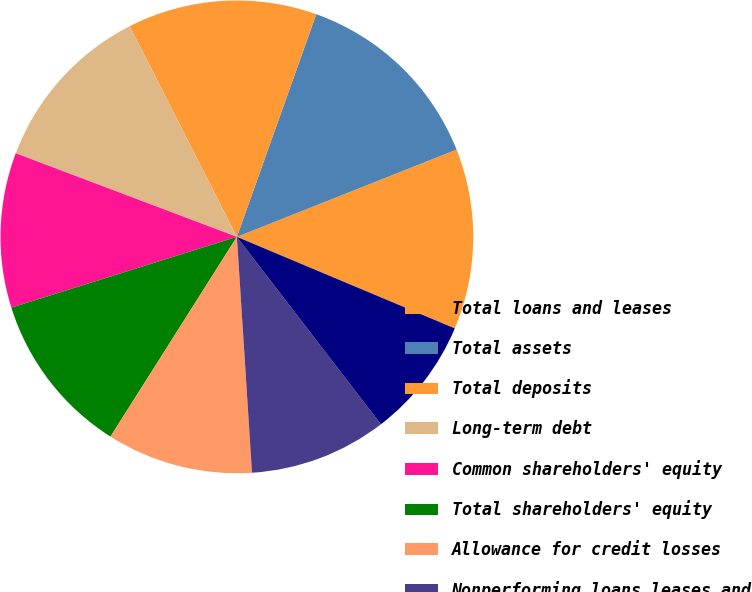Convert chart to OTSL. <chart><loc_0><loc_0><loc_500><loc_500><pie_chart><fcel>Total loans and leases<fcel>Total assets<fcel>Total deposits<fcel>Long-term debt<fcel>Common shareholders' equity<fcel>Total shareholders' equity<fcel>Allowance for credit losses<fcel>Nonperforming loans leases and<fcel>Allowance for loan and lease<nl><fcel>12.35%<fcel>13.53%<fcel>12.94%<fcel>11.76%<fcel>10.59%<fcel>11.18%<fcel>10.0%<fcel>9.41%<fcel>8.24%<nl></chart> 